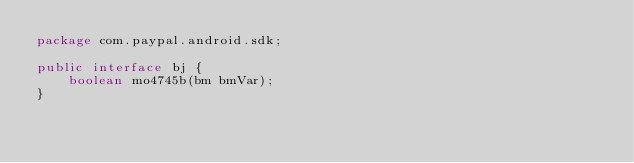<code> <loc_0><loc_0><loc_500><loc_500><_Java_>package com.paypal.android.sdk;

public interface bj {
    boolean mo4745b(bm bmVar);
}
</code> 